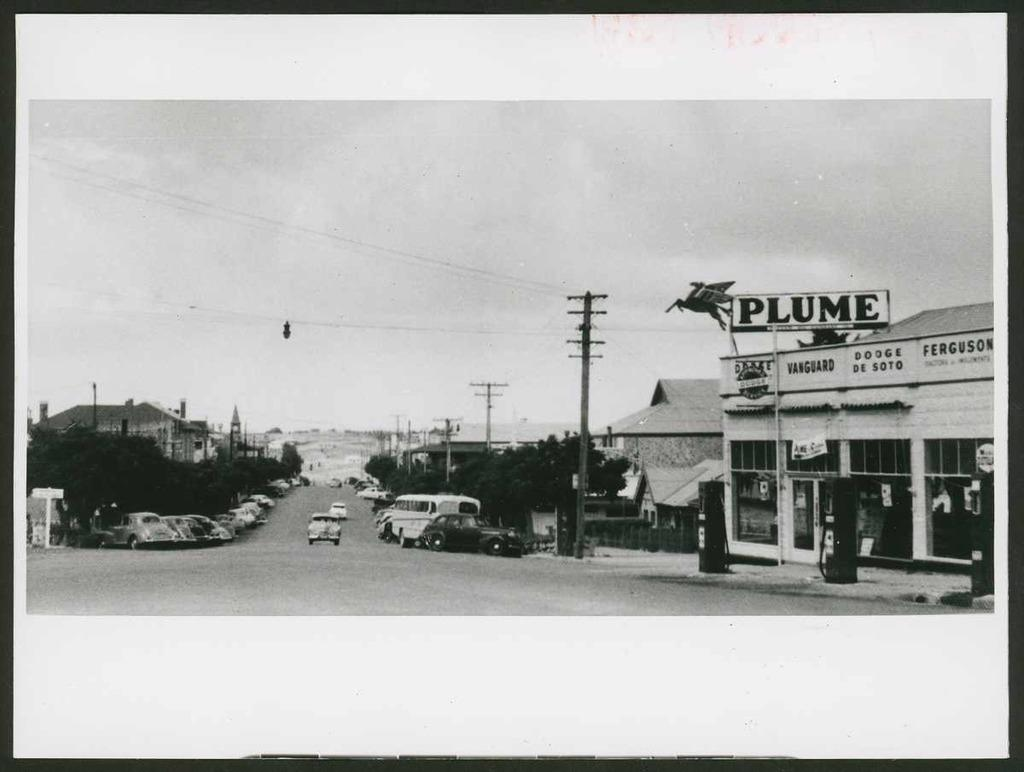Provide a one-sentence caption for the provided image. Black and white picture of cars parked outside a store named Plume. 